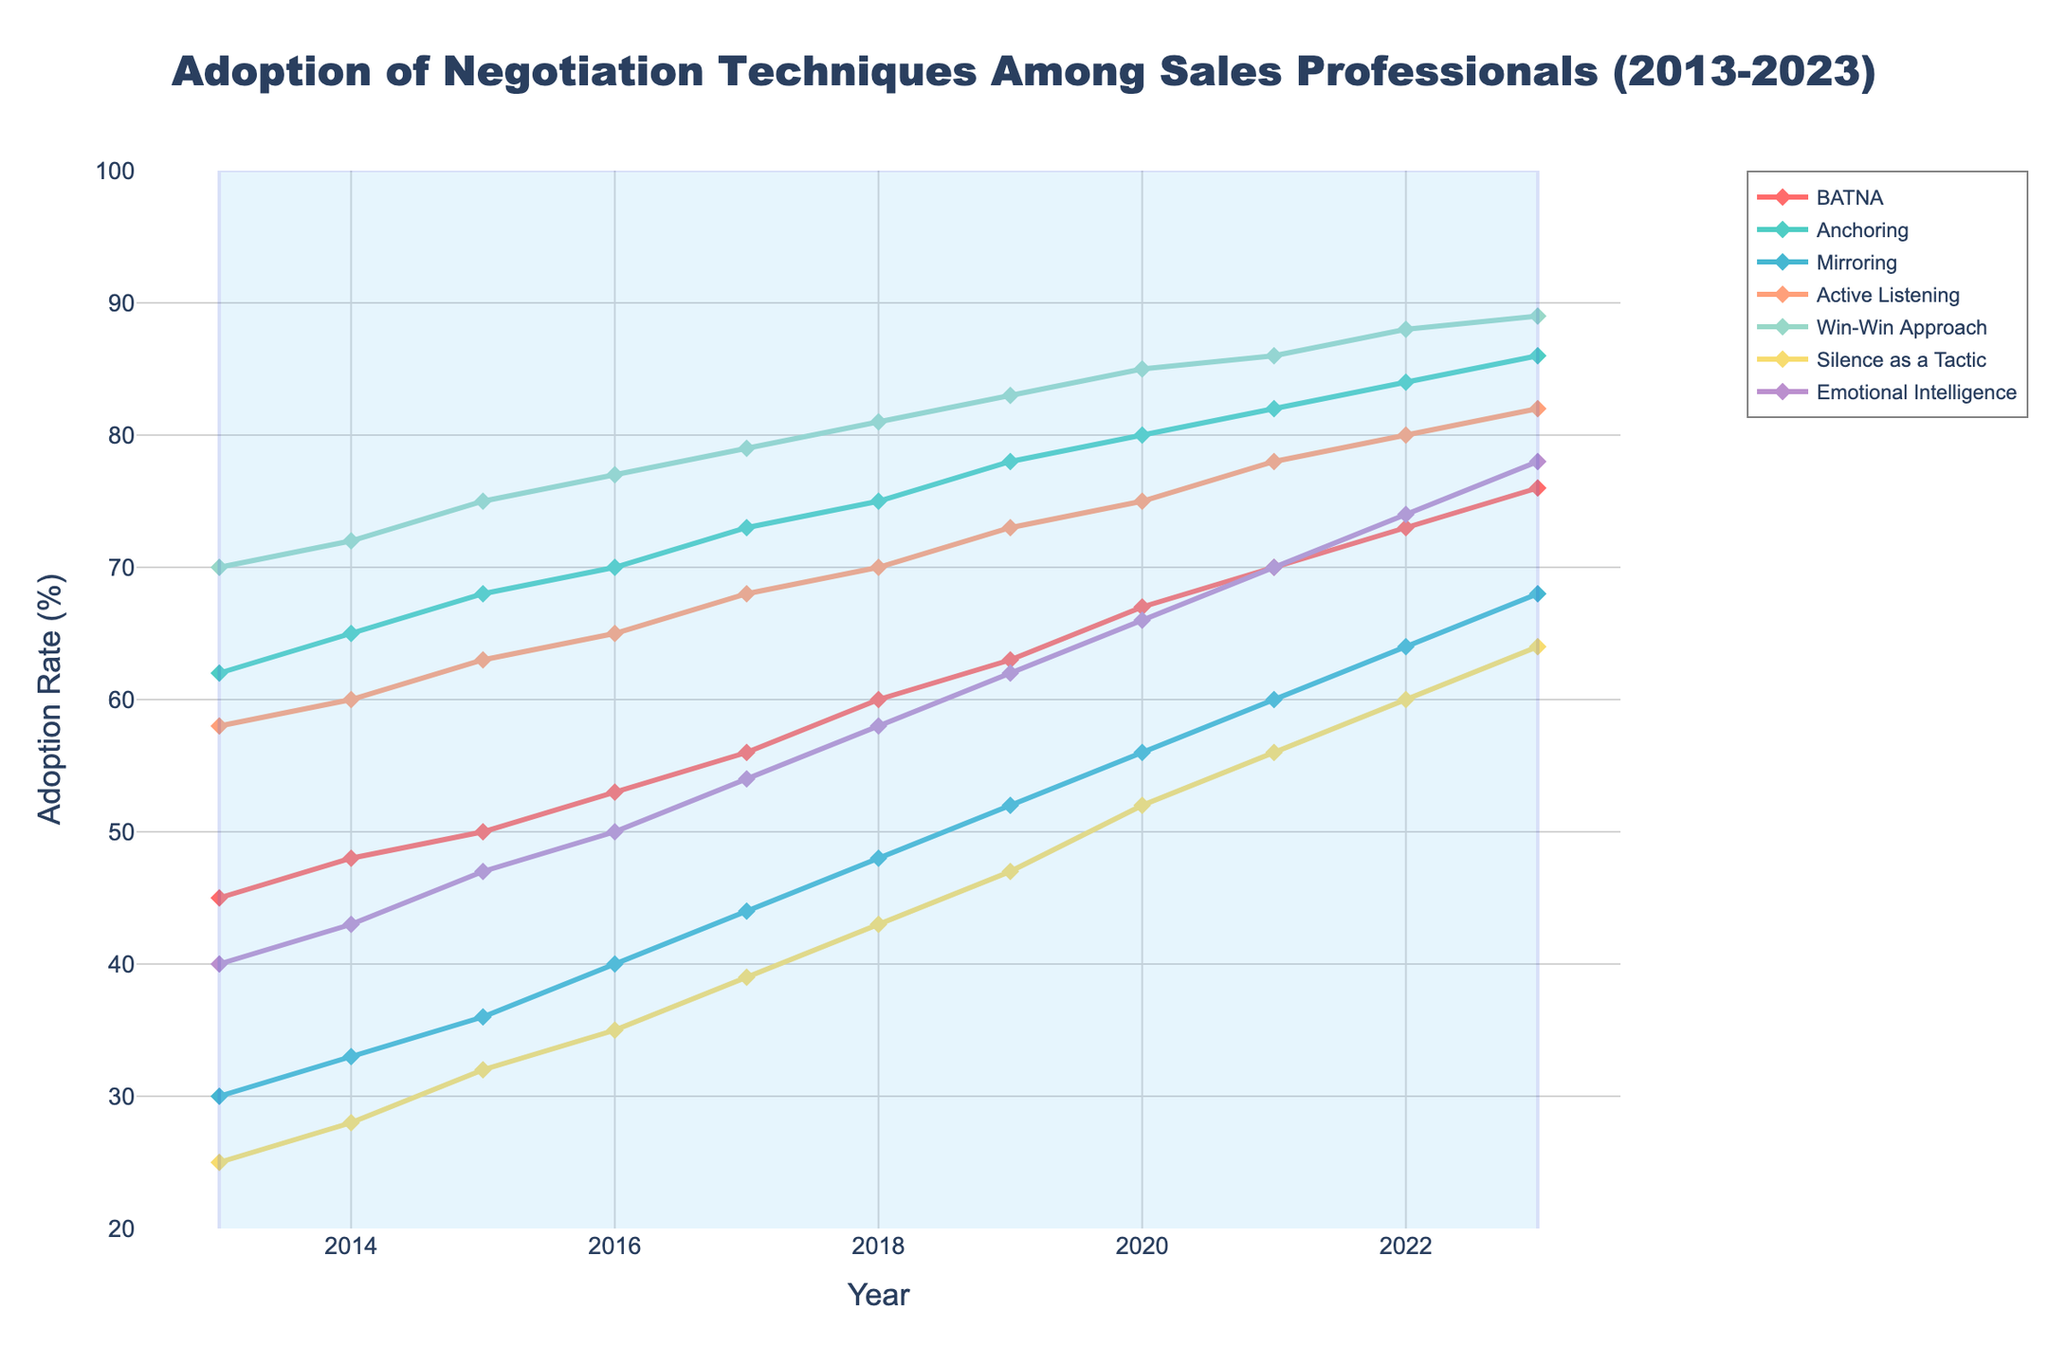What's the general trend of BATNA adoption rates from 2013 to 2023? The figure shows a consistent upward trend in the line representing BATNA from 2013 to 2023. It starts at 45% in 2013 and increases steadily each year, reaching 76% in 2023.
Answer: Increasing Which negotiation technique had the highest adoption rate in 2023? By looking at the end of the lines for the year 2023, the "Win-Win Approach" has the highest adoption rate at 89%.
Answer: Win-Win Approach What is the difference in the adoption rate of "Anchoring" between 2013 and 2023? In 2013, the adoption rate for "Anchoring" was 62%, and in 2023, it was 86%. Subtracting 62 from 86 gives a difference of 24%.
Answer: 24% Which negotiation techniques had an adoption rate below 50% in 2013? By examining the start of the lines for 2013, "Mirroring", "Silence as a Tactic", and "Emotional Intelligence" had adoption rates of 30%, 25%, and 40%, respectively—all below 50%.
Answer: Mirroring, Silence as a Tactic, Emotional Intelligence How many negotiation techniques had an adoption rate of 70% or more in 2020? Looking at the rates in 2020, the techniques with adoption rates of 70% or more are "Anchoring" (80%), "Active Listening" (75%), "Win-Win Approach" (85%), and "Emotional Intelligence" (66%)—four techniques in total.
Answer: 4 Which technique showed the maximum increase in adoption rate from 2013 to 2023? Calculating the differences for each technique, "BATNA" increased by 31%, "Anchoring" by 24%, "Mirroring" by 38%, "Active Listening" by 24%, "Win-Win Approach" by 19%, "Silence as a Tactic" by 39%, and "Emotional Intelligence" by 38%. "Silence as a Tactic" and "Mirroring" showed the maximum increase of 39% and 38%.
Answer: Silence as a Tactic Which technique had the smallest increase in adoption rate from 2013 to 2023? Among the techniques, "Win-Win Approach" had the smallest increase in adoption rate, rising from 70% in 2013 to 89% in 2023, a 19% increase.
Answer: Win-Win Approach What is the average adoption rate of "Active Listening" from 2013 to 2023? Adding up the adoption rates for "Active Listening" across all years and then dividing by 11, the average is (58 + 60 + 63 + 65 + 68 + 70 + 73 + 75 + 78 + 80 + 82) / 11 = 72.
Answer: 72 Compare the adoption rates of "BATNA" and "Emotional Intelligence" in 2019. Which one was higher and by how much? In 2019, "BATNA" had an adoption rate of 63% and "Emotional Intelligence" had an adoption rate of 62%. "BATNA" was higher by 1%.
Answer: BATNA by 1% 